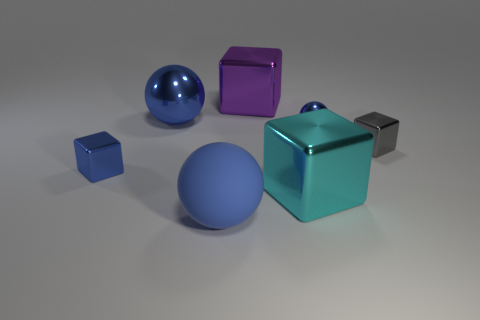Add 1 big brown objects. How many objects exist? 8 Subtract all balls. How many objects are left? 4 Add 3 purple metal blocks. How many purple metal blocks exist? 4 Subtract 3 blue balls. How many objects are left? 4 Subtract all shiny balls. Subtract all small shiny spheres. How many objects are left? 4 Add 3 gray cubes. How many gray cubes are left? 4 